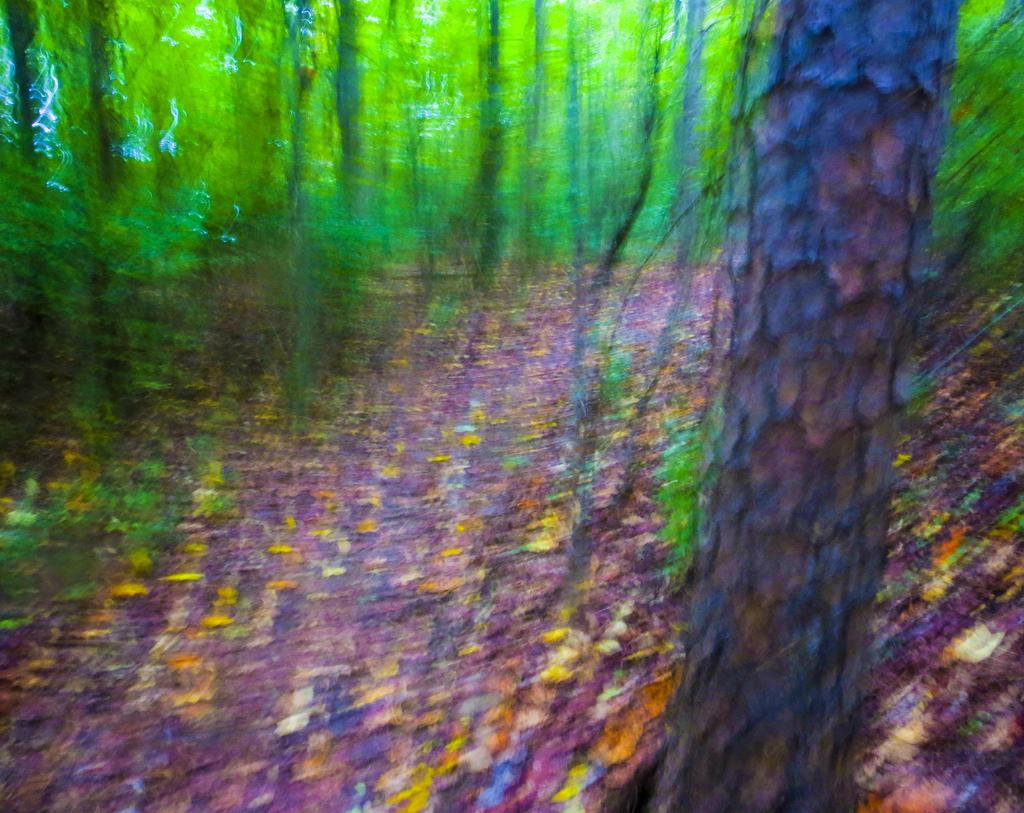What is the overall quality of the image? The image is blurry. What type of surface can be seen in the image? There is ground visible in the image. What is present on the ground? There are leaves on the ground. What type of vegetation is present in the image? There are trees in the image. What is the color of the trees? The trees are green in color. What type of lettuce can be seen growing in the image? There is no lettuce present in the image; it features trees and leaves on the ground. Can you tell me how many people are swimming in the image? There is no swimming or people present in the image; it is a blurry image of trees and leaves on the ground. 